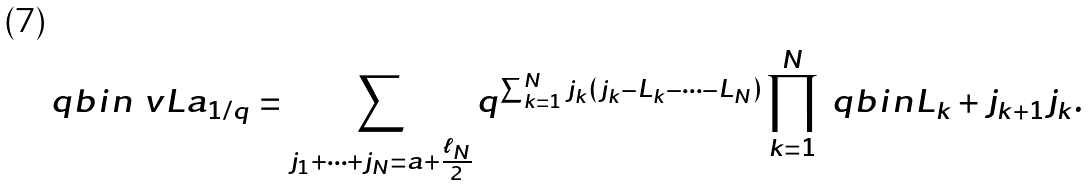Convert formula to latex. <formula><loc_0><loc_0><loc_500><loc_500>\ q b i n { \ v L } { a } _ { 1 / q } = \sum _ { j _ { 1 } + \cdots + j _ { N } = a + \frac { \ell _ { N } } { 2 } } q ^ { \sum _ { k = 1 } ^ { N } j _ { k } ( j _ { k } - L _ { k } - \cdots - L _ { N } ) } \prod _ { k = 1 } ^ { N } \ q b i n { L _ { k } + j _ { k + 1 } } { j _ { k } } .</formula> 